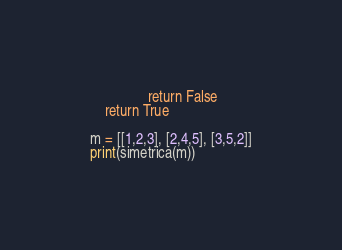<code> <loc_0><loc_0><loc_500><loc_500><_Python_>                return False
    return True

m = [[1,2,3], [2,4,5], [3,5,2]]
print(simetrica(m))
</code> 